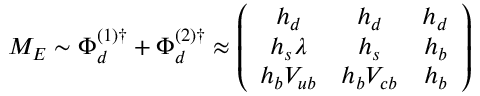Convert formula to latex. <formula><loc_0><loc_0><loc_500><loc_500>M _ { E } \sim \Phi _ { d } ^ { ( 1 ) \dagger } + \Phi _ { d } ^ { ( 2 ) \dagger } \approx \left ( \begin{array} { c c c } { { h _ { d } } } & { { h _ { d } } } & { { h _ { d } } } \\ { { h _ { s } \lambda } } & { { h _ { s } } } & { { h _ { b } } } \\ { { h _ { b } V _ { u b } } } & { { h _ { b } V _ { c b } } } & { { h _ { b } } } \end{array} \right )</formula> 